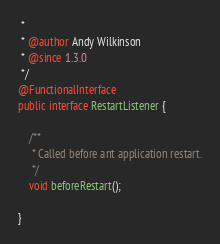<code> <loc_0><loc_0><loc_500><loc_500><_Java_> *
 * @author Andy Wilkinson
 * @since 1.3.0
 */
@FunctionalInterface
public interface RestartListener {

	/**
	 * Called before ant application restart.
	 */
	void beforeRestart();

}
</code> 